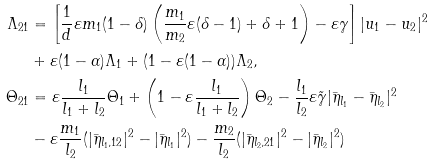<formula> <loc_0><loc_0><loc_500><loc_500>\Lambda _ { 2 1 } & = \left [ \frac { 1 } { d } \varepsilon m _ { 1 } ( 1 - \delta ) \left ( \frac { m _ { 1 } } { m _ { 2 } } \varepsilon ( \delta - 1 ) + \delta + 1 \right ) - \varepsilon \gamma \right ] | u _ { 1 } - u _ { 2 } | ^ { 2 } \\ & + \varepsilon ( 1 - \alpha ) \Lambda _ { 1 } + ( 1 - \varepsilon ( 1 - \alpha ) ) \Lambda _ { 2 } , \\ \Theta _ { 2 1 } & = \varepsilon \frac { l _ { 1 } } { l _ { 1 } + l _ { 2 } } \Theta _ { 1 } + \left ( 1 - \varepsilon \frac { l _ { 1 } } { l _ { 1 } + l _ { 2 } } \right ) \Theta _ { 2 } - \frac { l _ { 1 } } { l _ { 2 } } \varepsilon \tilde { \gamma } | \bar { \eta } _ { l _ { 1 } } - \bar { \eta } _ { l _ { 2 } } | ^ { 2 } \\ & - \varepsilon \frac { m _ { 1 } } { l _ { 2 } } ( | \bar { \eta } _ { l _ { 1 } , 1 2 } | ^ { 2 } - | \bar { \eta } _ { l _ { 1 } } | ^ { 2 } ) - \frac { m _ { 2 } } { l _ { 2 } } ( | \bar { \eta } _ { l _ { 2 } , 2 1 } | ^ { 2 } - | \bar { \eta } _ { l _ { 2 } } | ^ { 2 } )</formula> 